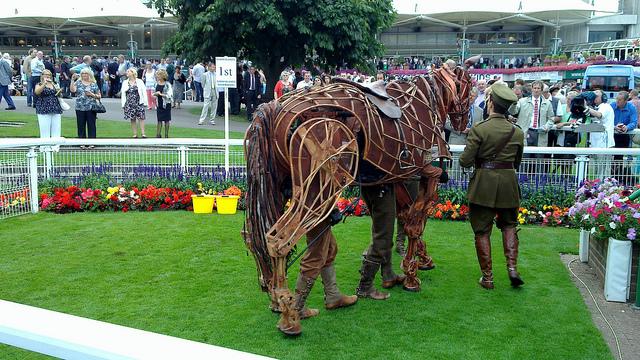What number is on the sign?
Short answer required. 1. What is the horse made of?
Write a very short answer. Metal. Is the horse trying to make a fashion statement?
Short answer required. No. 